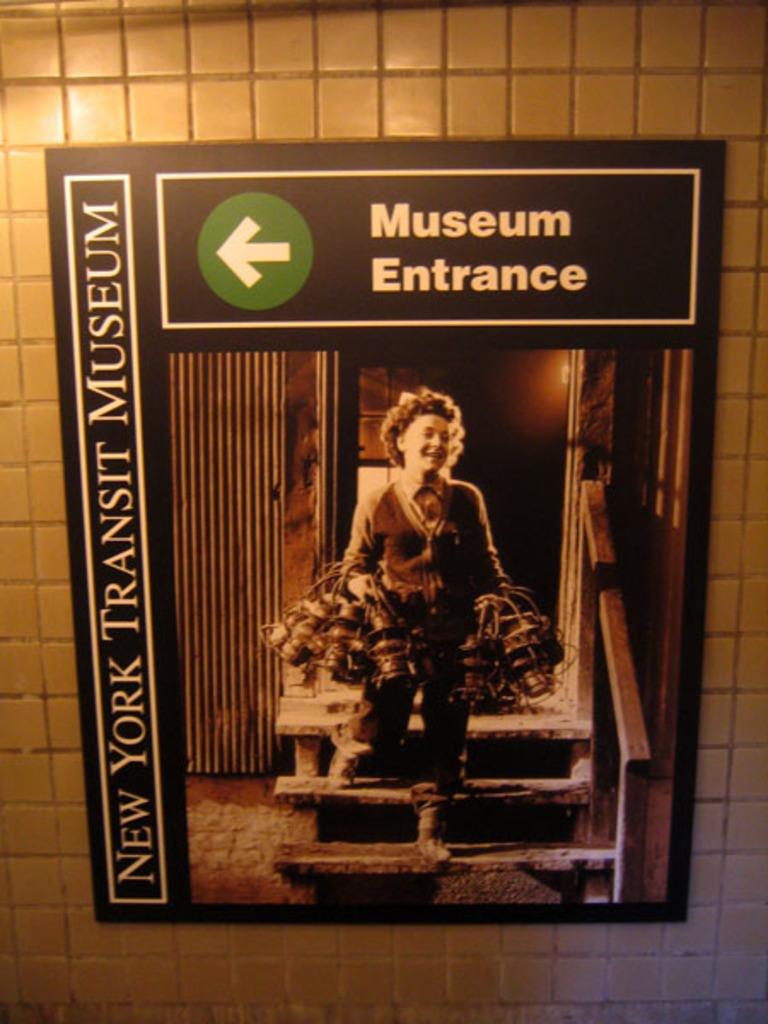Which way to the entrance?
Ensure brevity in your answer.  Answering does not require reading text in the image. What museum is shown on this advertisement?
Provide a short and direct response. New york transit museum. 